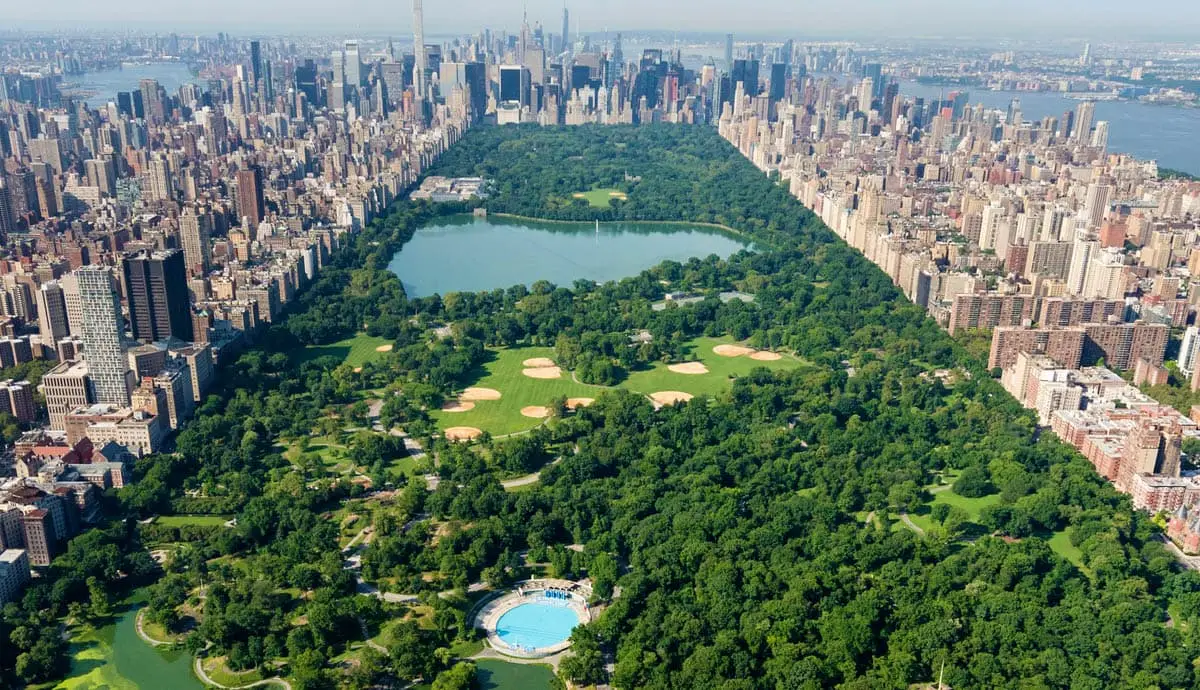What are the ecological aspects highlighted in this photo of Central Park? The image underscores Central Park's role as an ecological haven in New York City, featuring its diverse array of flora and dedicated wildlife areas. The park functions as a green lung, improving urban air quality and providing a habitat for various wildlife species, including migratory birds, which utilize the park's woodlands and water bodies as resting and feeding sites. The vegetation helps regulate air temperatures during the city's hot summers, and the large water bodies play a role in stormwater management, reducing urban runoff and enhancing water quality. 